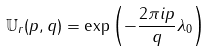Convert formula to latex. <formula><loc_0><loc_0><loc_500><loc_500>\mathbb { U } _ { r } ( p , q ) = \exp \left ( - \frac { 2 \pi i p } { q } \lambda _ { 0 } \right )</formula> 